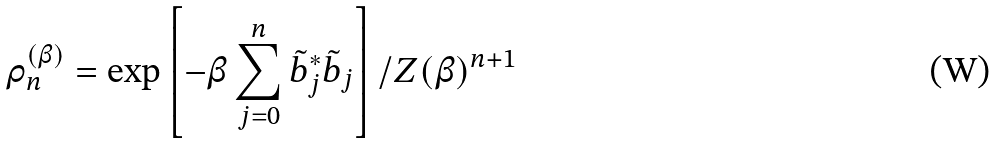<formula> <loc_0><loc_0><loc_500><loc_500>\rho ^ { ( \beta ) } _ { n } = \exp \left [ - \beta \sum _ { j = 0 } ^ { n } \tilde { b } ^ { * } _ { j } \tilde { b } _ { j } \right ] / Z ( \beta ) ^ { n + 1 }</formula> 